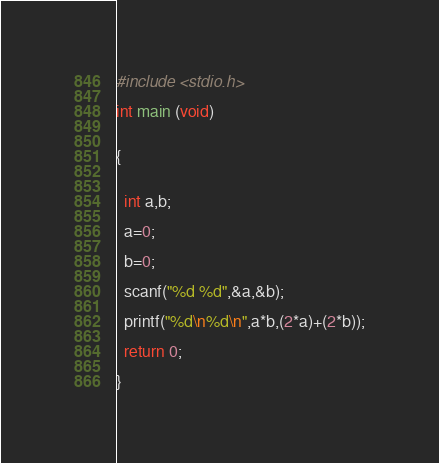Convert code to text. <code><loc_0><loc_0><loc_500><loc_500><_C_>#include <stdio.h>

int main (void)


{


  int a,b;

  a=0;

  b=0;
 
  scanf("%d %d",&a,&b);

  printf("%d\n%d\n",a*b,(2*a)+(2*b));

  return 0;

}</code> 